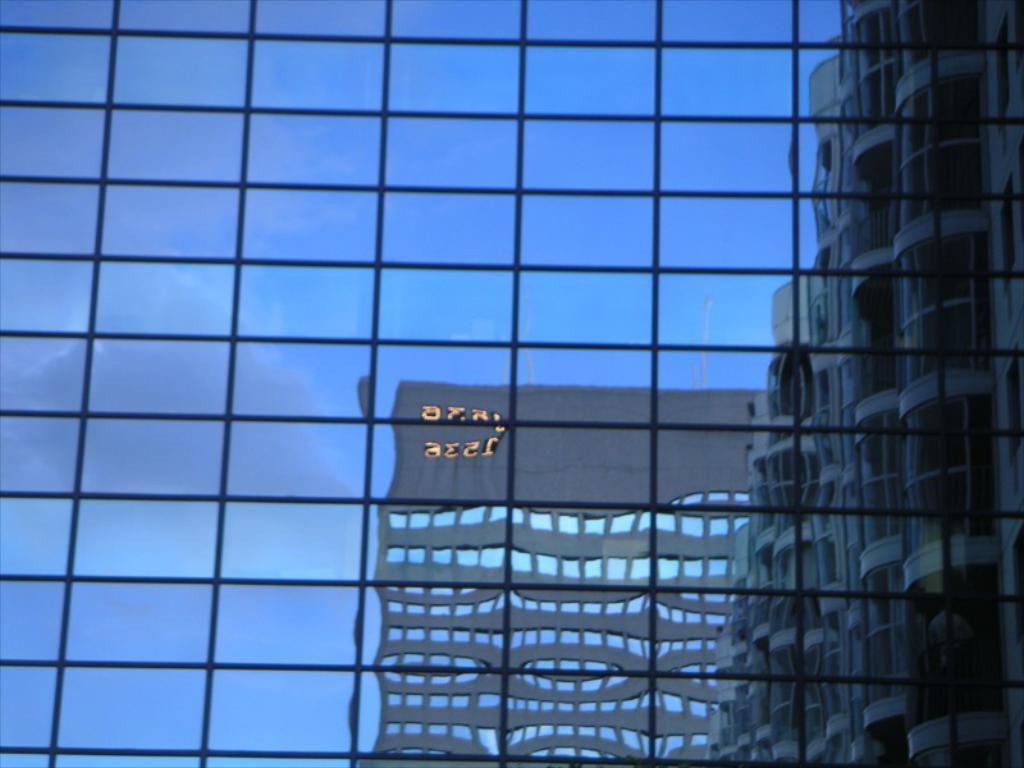What type of structure is present in the image? There is a glass window in the image. What can be seen through the glass window? Buildings and the sky are visible through the glass window. What type of story is being told by the manager in the image? There is no manager or story present in the image; it only features a glass window with buildings and the sky visible through it. 